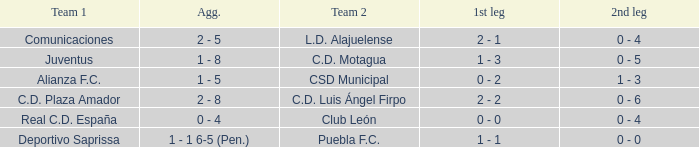What is the 1st leg where Team 1 is C.D. Plaza Amador? 2 - 2. 